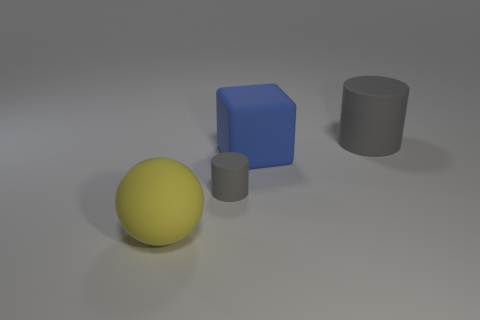There is a matte object that is the same color as the large cylinder; what shape is it?
Ensure brevity in your answer.  Cylinder. Is there any other thing that is the same color as the large rubber cylinder?
Make the answer very short. Yes. The object that is right of the large rubber ball and in front of the rubber block has what shape?
Your answer should be very brief. Cylinder. How many objects are rubber cubes or gray things behind the large blue thing?
Give a very brief answer. 2. How many other things are the same shape as the large gray matte object?
Your answer should be compact. 1. How big is the thing that is in front of the blue rubber cube and behind the matte sphere?
Your answer should be compact. Small. What number of shiny things are small cylinders or brown cylinders?
Offer a terse response. 0. There is a big thing that is right of the big blue matte object; does it have the same shape as the gray thing on the left side of the large gray matte thing?
Offer a very short reply. Yes. Are there any cyan cylinders that have the same material as the ball?
Your response must be concise. No. What is the color of the large cube?
Offer a very short reply. Blue. 